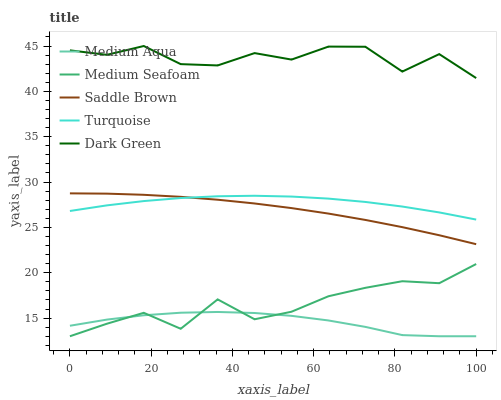Does Medium Aqua have the minimum area under the curve?
Answer yes or no. Yes. Does Dark Green have the maximum area under the curve?
Answer yes or no. Yes. Does Dark Green have the minimum area under the curve?
Answer yes or no. No. Does Medium Aqua have the maximum area under the curve?
Answer yes or no. No. Is Saddle Brown the smoothest?
Answer yes or no. Yes. Is Dark Green the roughest?
Answer yes or no. Yes. Is Medium Aqua the smoothest?
Answer yes or no. No. Is Medium Aqua the roughest?
Answer yes or no. No. Does Dark Green have the lowest value?
Answer yes or no. No. Does Dark Green have the highest value?
Answer yes or no. Yes. Does Medium Aqua have the highest value?
Answer yes or no. No. Is Medium Seafoam less than Dark Green?
Answer yes or no. Yes. Is Dark Green greater than Saddle Brown?
Answer yes or no. Yes. Does Turquoise intersect Saddle Brown?
Answer yes or no. Yes. Is Turquoise less than Saddle Brown?
Answer yes or no. No. Is Turquoise greater than Saddle Brown?
Answer yes or no. No. Does Medium Seafoam intersect Dark Green?
Answer yes or no. No. 